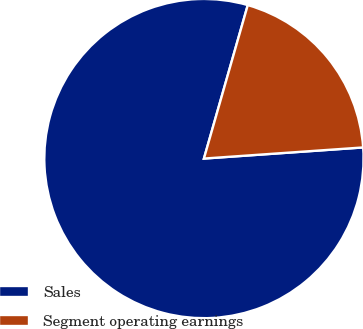<chart> <loc_0><loc_0><loc_500><loc_500><pie_chart><fcel>Sales<fcel>Segment operating earnings<nl><fcel>80.54%<fcel>19.46%<nl></chart> 